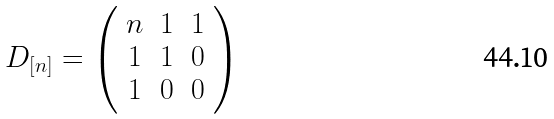Convert formula to latex. <formula><loc_0><loc_0><loc_500><loc_500>D _ { [ n ] } = \left ( \begin{array} { c c c } n & 1 & 1 \\ 1 & 1 & 0 \\ 1 & 0 & 0 \\ \end{array} \right )</formula> 